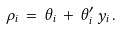<formula> <loc_0><loc_0><loc_500><loc_500>\rho _ { i } \, = \, \theta _ { i } \, + \, \theta _ { i } ^ { \prime } \, y _ { i } \, .</formula> 